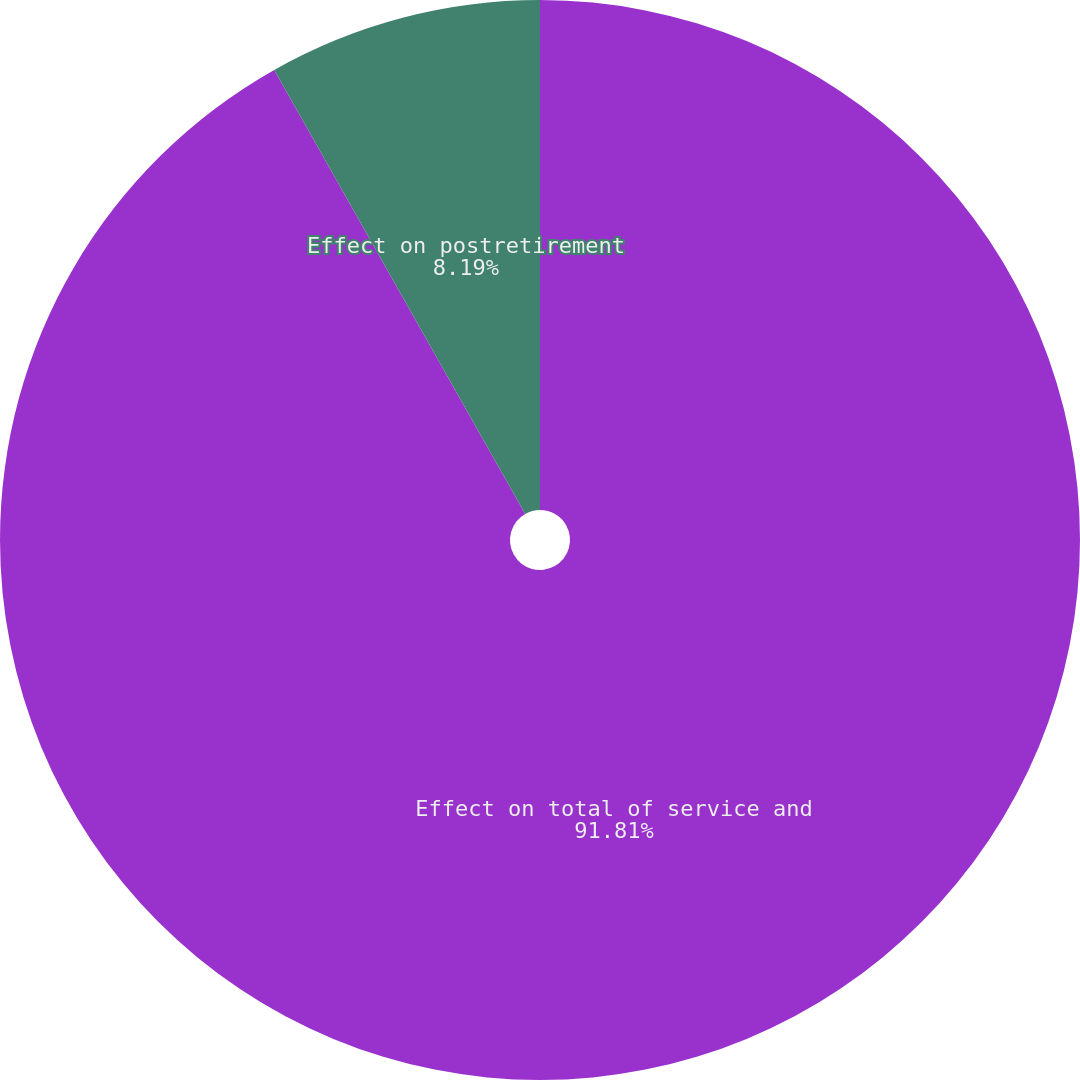<chart> <loc_0><loc_0><loc_500><loc_500><pie_chart><fcel>Effect on total of service and<fcel>Effect on postretirement<nl><fcel>91.81%<fcel>8.19%<nl></chart> 